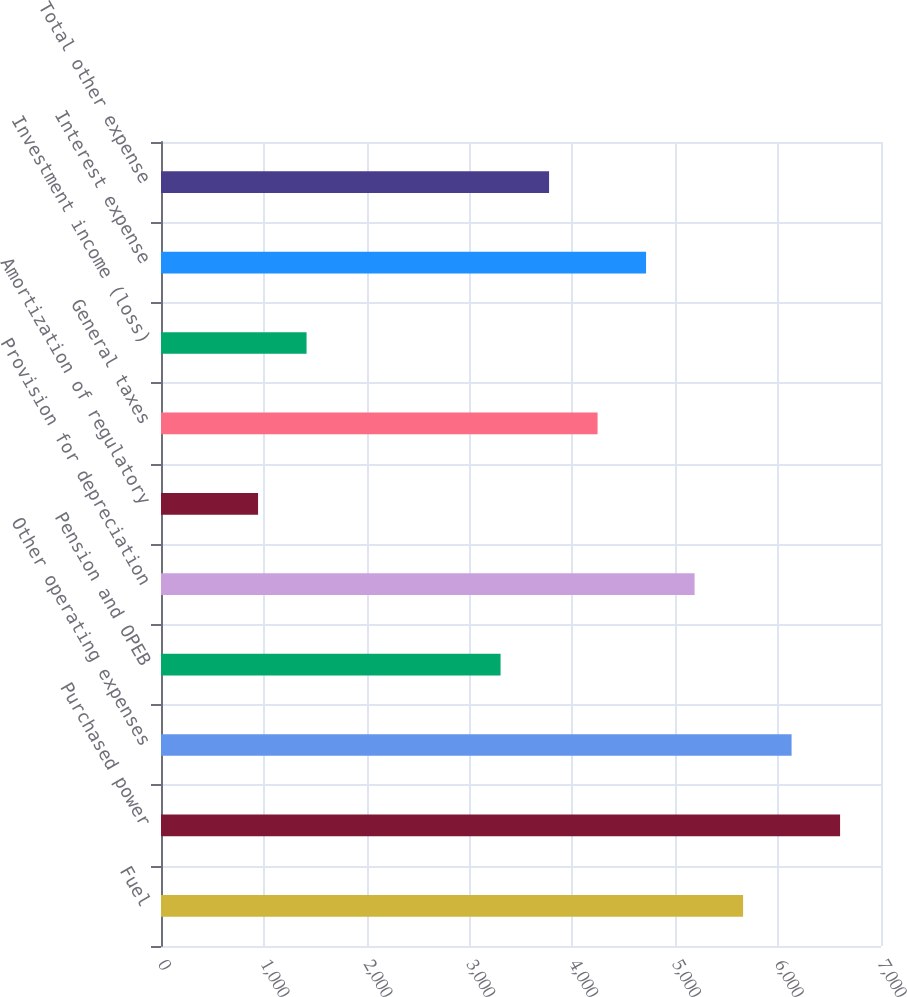Convert chart. <chart><loc_0><loc_0><loc_500><loc_500><bar_chart><fcel>Fuel<fcel>Purchased power<fcel>Other operating expenses<fcel>Pension and OPEB<fcel>Provision for depreciation<fcel>Amortization of regulatory<fcel>General taxes<fcel>Investment income (loss)<fcel>Interest expense<fcel>Total other expense<nl><fcel>5659.11<fcel>6602.21<fcel>6130.66<fcel>3301.36<fcel>5187.56<fcel>943.61<fcel>4244.46<fcel>1415.16<fcel>4716.01<fcel>3772.91<nl></chart> 